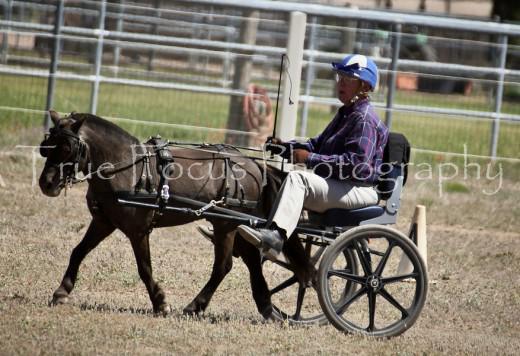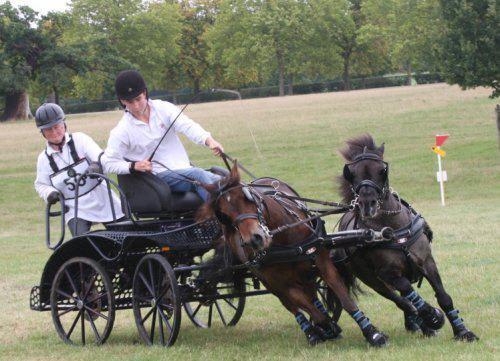The first image is the image on the left, the second image is the image on the right. For the images displayed, is the sentence "A pony's mane hair is flying in the right image." factually correct? Answer yes or no. Yes. The first image is the image on the left, the second image is the image on the right. Analyze the images presented: Is the assertion "There is no more than one person in the left image." valid? Answer yes or no. Yes. 